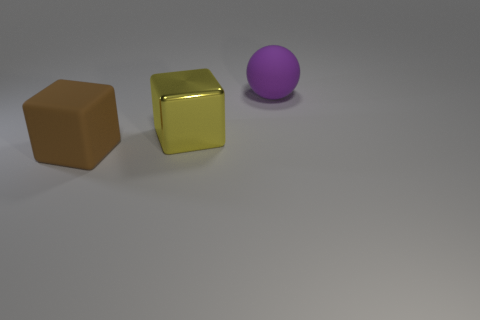Add 3 small yellow rubber balls. How many objects exist? 6 Subtract all blocks. How many objects are left? 1 Add 1 big things. How many big things are left? 4 Add 2 purple cylinders. How many purple cylinders exist? 2 Subtract 1 yellow blocks. How many objects are left? 2 Subtract all big yellow blocks. Subtract all large brown blocks. How many objects are left? 1 